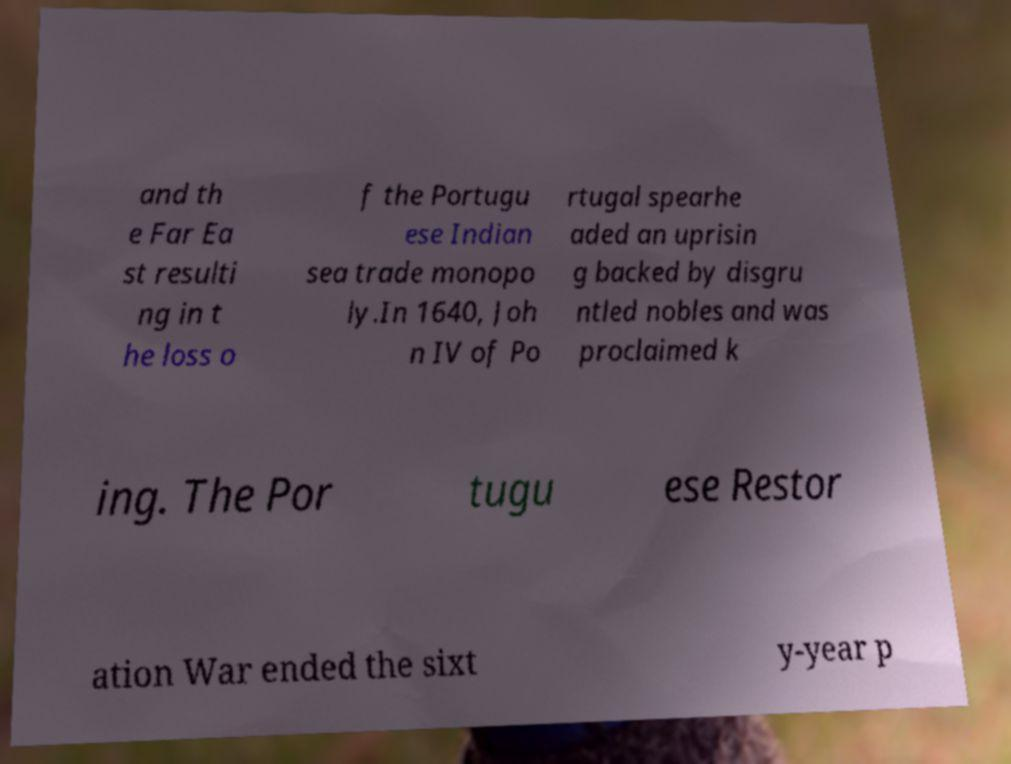Could you extract and type out the text from this image? and th e Far Ea st resulti ng in t he loss o f the Portugu ese Indian sea trade monopo ly.In 1640, Joh n IV of Po rtugal spearhe aded an uprisin g backed by disgru ntled nobles and was proclaimed k ing. The Por tugu ese Restor ation War ended the sixt y-year p 